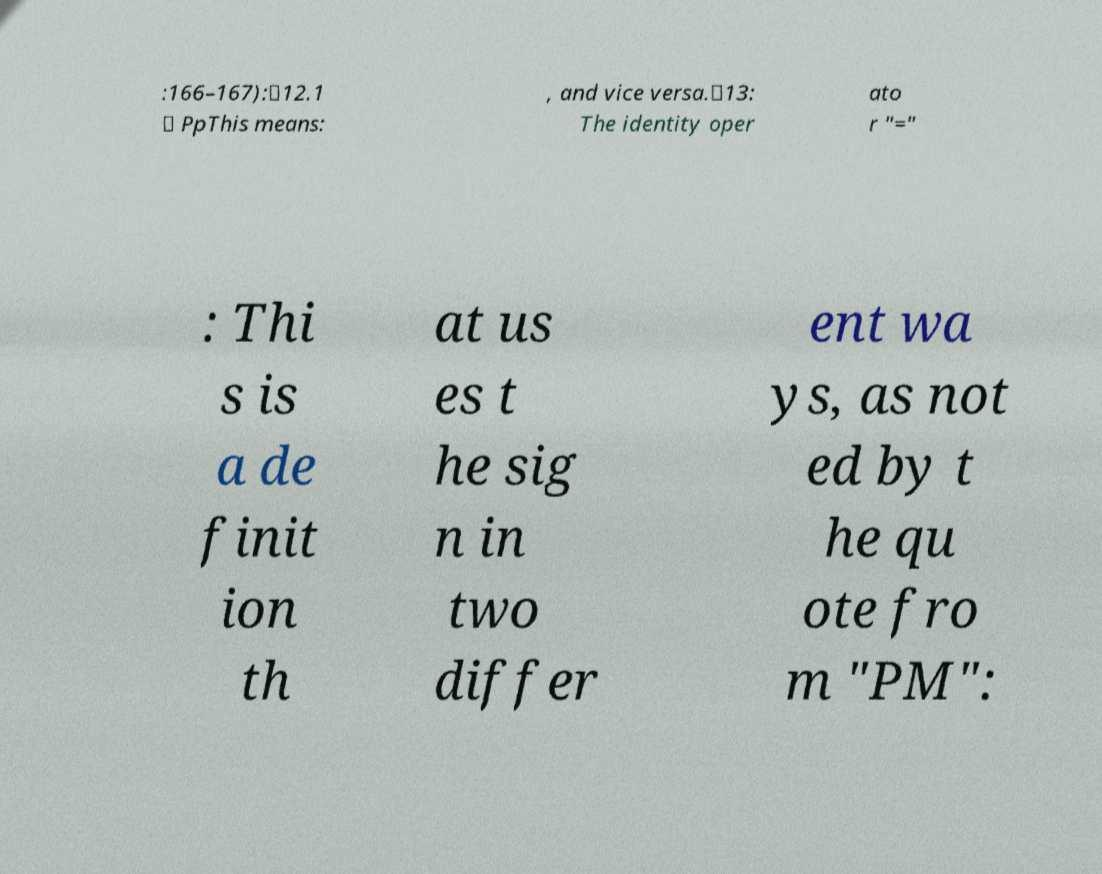I need the written content from this picture converted into text. Can you do that? :166–167):✸12.1 ⊢ PpThis means: , and vice versa.✸13: The identity oper ato r "=" : Thi s is a de finit ion th at us es t he sig n in two differ ent wa ys, as not ed by t he qu ote fro m "PM": 